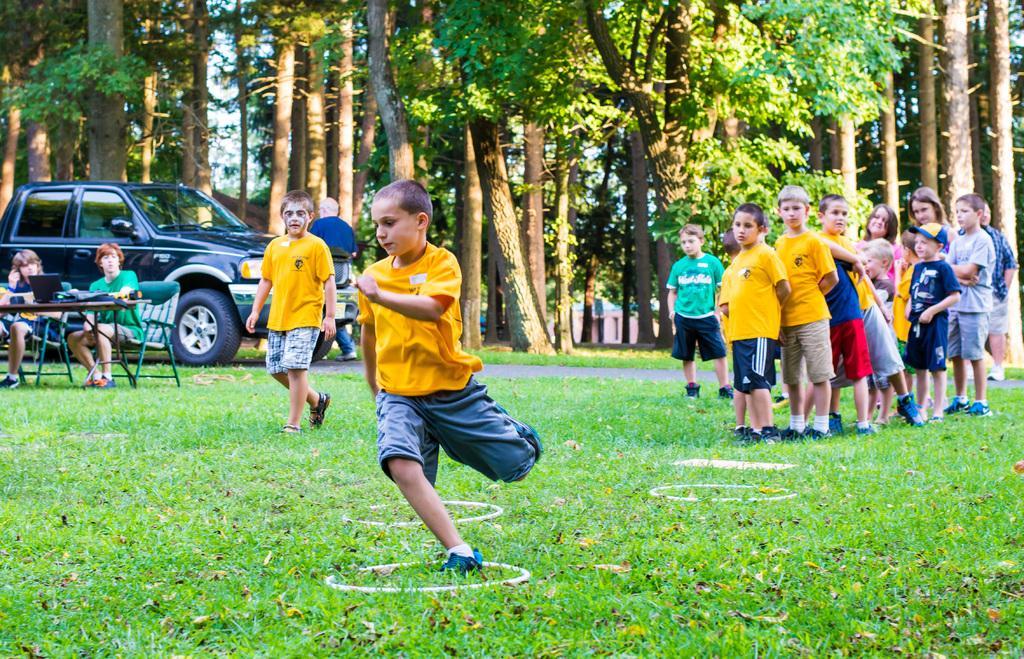Can you describe this image briefly? In this picture we can see a group of children, rings on the grass, two people sitting on chairs, laptop and some objects on the table, vehicle, man, trees and in the background we can see the sky. 